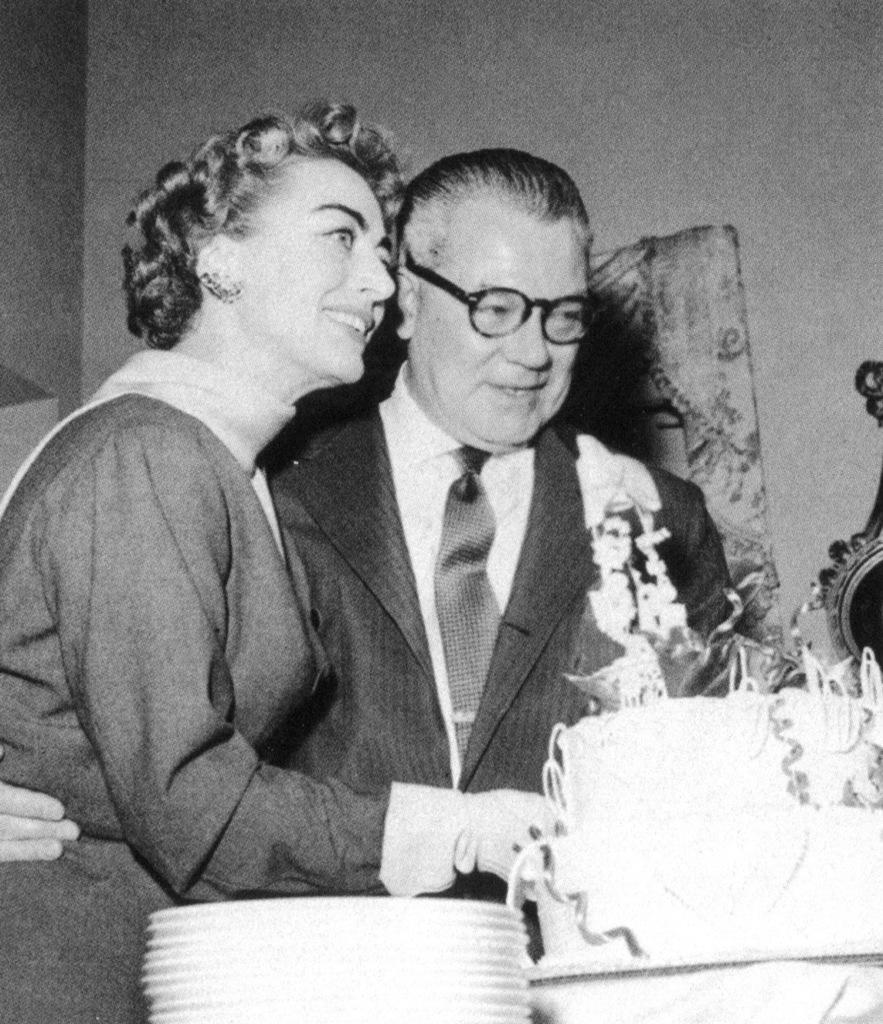How would you summarize this image in a sentence or two? In this picture we can see a man and a woman, they both are smiling and he wore spectacles, in front of them we can find a cake and plates. 